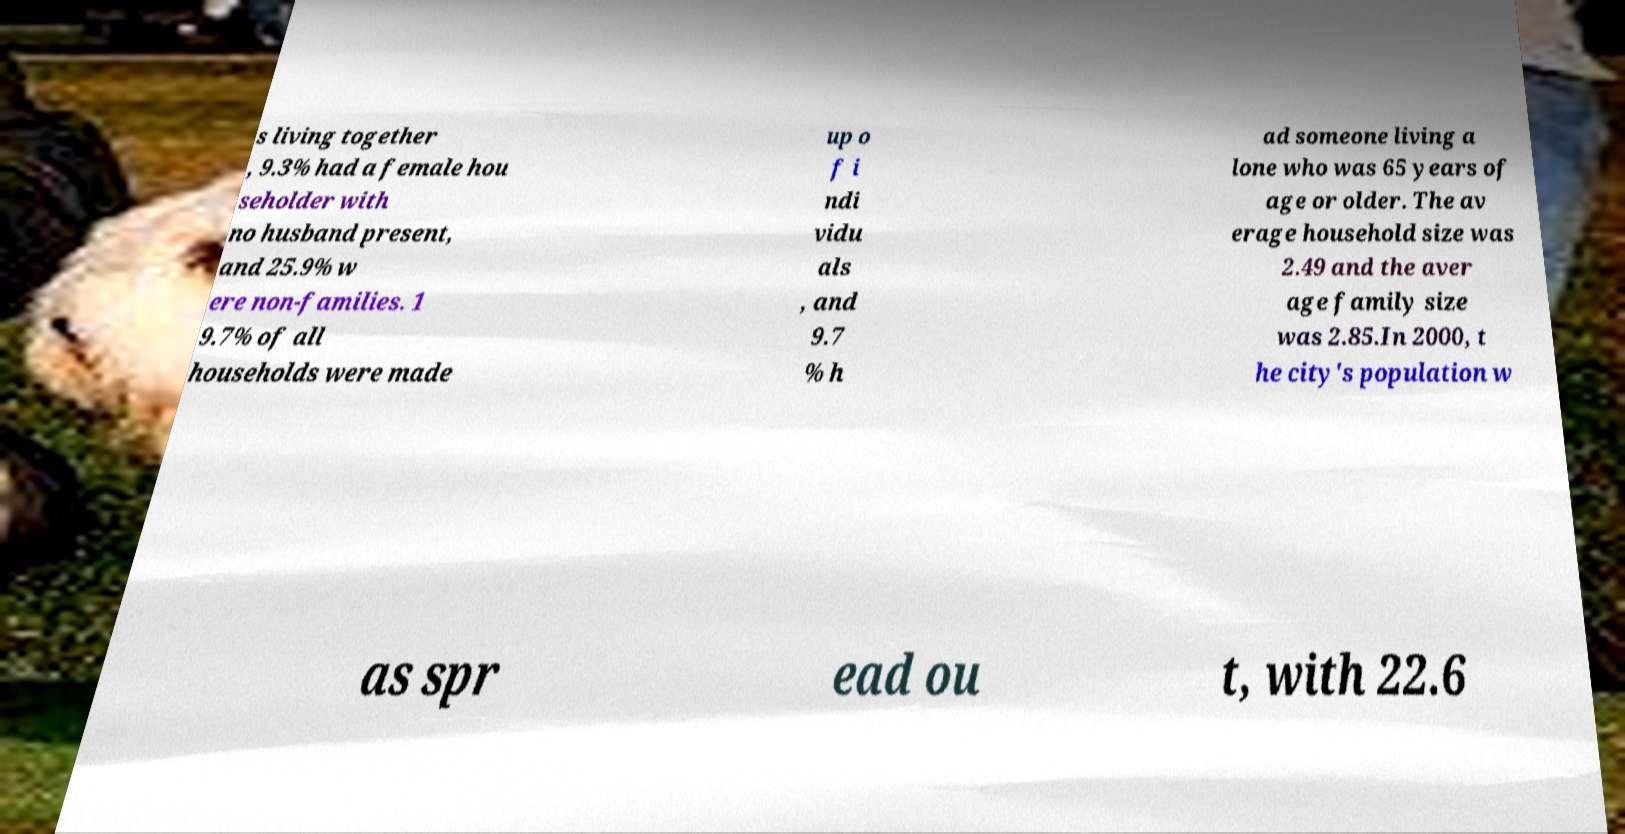There's text embedded in this image that I need extracted. Can you transcribe it verbatim? s living together , 9.3% had a female hou seholder with no husband present, and 25.9% w ere non-families. 1 9.7% of all households were made up o f i ndi vidu als , and 9.7 % h ad someone living a lone who was 65 years of age or older. The av erage household size was 2.49 and the aver age family size was 2.85.In 2000, t he city's population w as spr ead ou t, with 22.6 